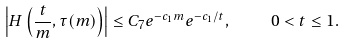<formula> <loc_0><loc_0><loc_500><loc_500>\left | H \left ( \frac { t } { m } , \tau ( m ) \right ) \right | \leq C _ { 7 } e ^ { - c _ { 1 } m } e ^ { - c _ { 1 } / t } , \quad 0 < t \leq 1 .</formula> 